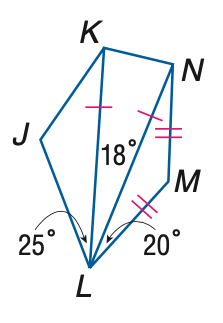Answer the mathemtical geometry problem and directly provide the correct option letter.
Question: \triangle K L N and \triangle L M N are isosceles and m \angle J K N = 130. Find the measure of \angle M.
Choices: A: 110 B: 120 C: 130 D: 140 D 